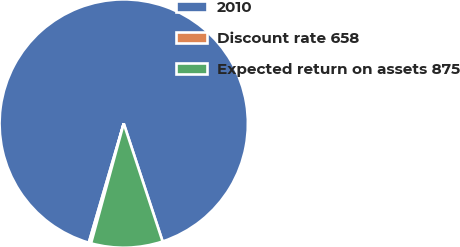Convert chart. <chart><loc_0><loc_0><loc_500><loc_500><pie_chart><fcel>2010<fcel>Discount rate 658<fcel>Expected return on assets 875<nl><fcel>90.39%<fcel>0.3%<fcel>9.31%<nl></chart> 